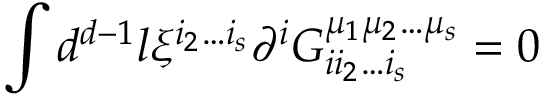<formula> <loc_0><loc_0><loc_500><loc_500>\int d ^ { d - 1 } l \xi ^ { i _ { 2 } \dots i _ { s } } \partial ^ { i } G _ { i i _ { 2 } \dots i _ { s } } ^ { \mu _ { 1 } \mu _ { 2 } \dots \mu _ { s } } = 0</formula> 